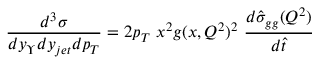<formula> <loc_0><loc_0><loc_500><loc_500>\frac { d ^ { 3 } \sigma } { d y _ { \Upsilon } d y _ { j e t } d p _ { T } } = 2 p _ { T } \ x ^ { 2 } g ( x , Q ^ { 2 } ) ^ { 2 } \ \frac { d \hat { \sigma } _ { g g } ( Q ^ { 2 } ) } { d \hat { t } }</formula> 